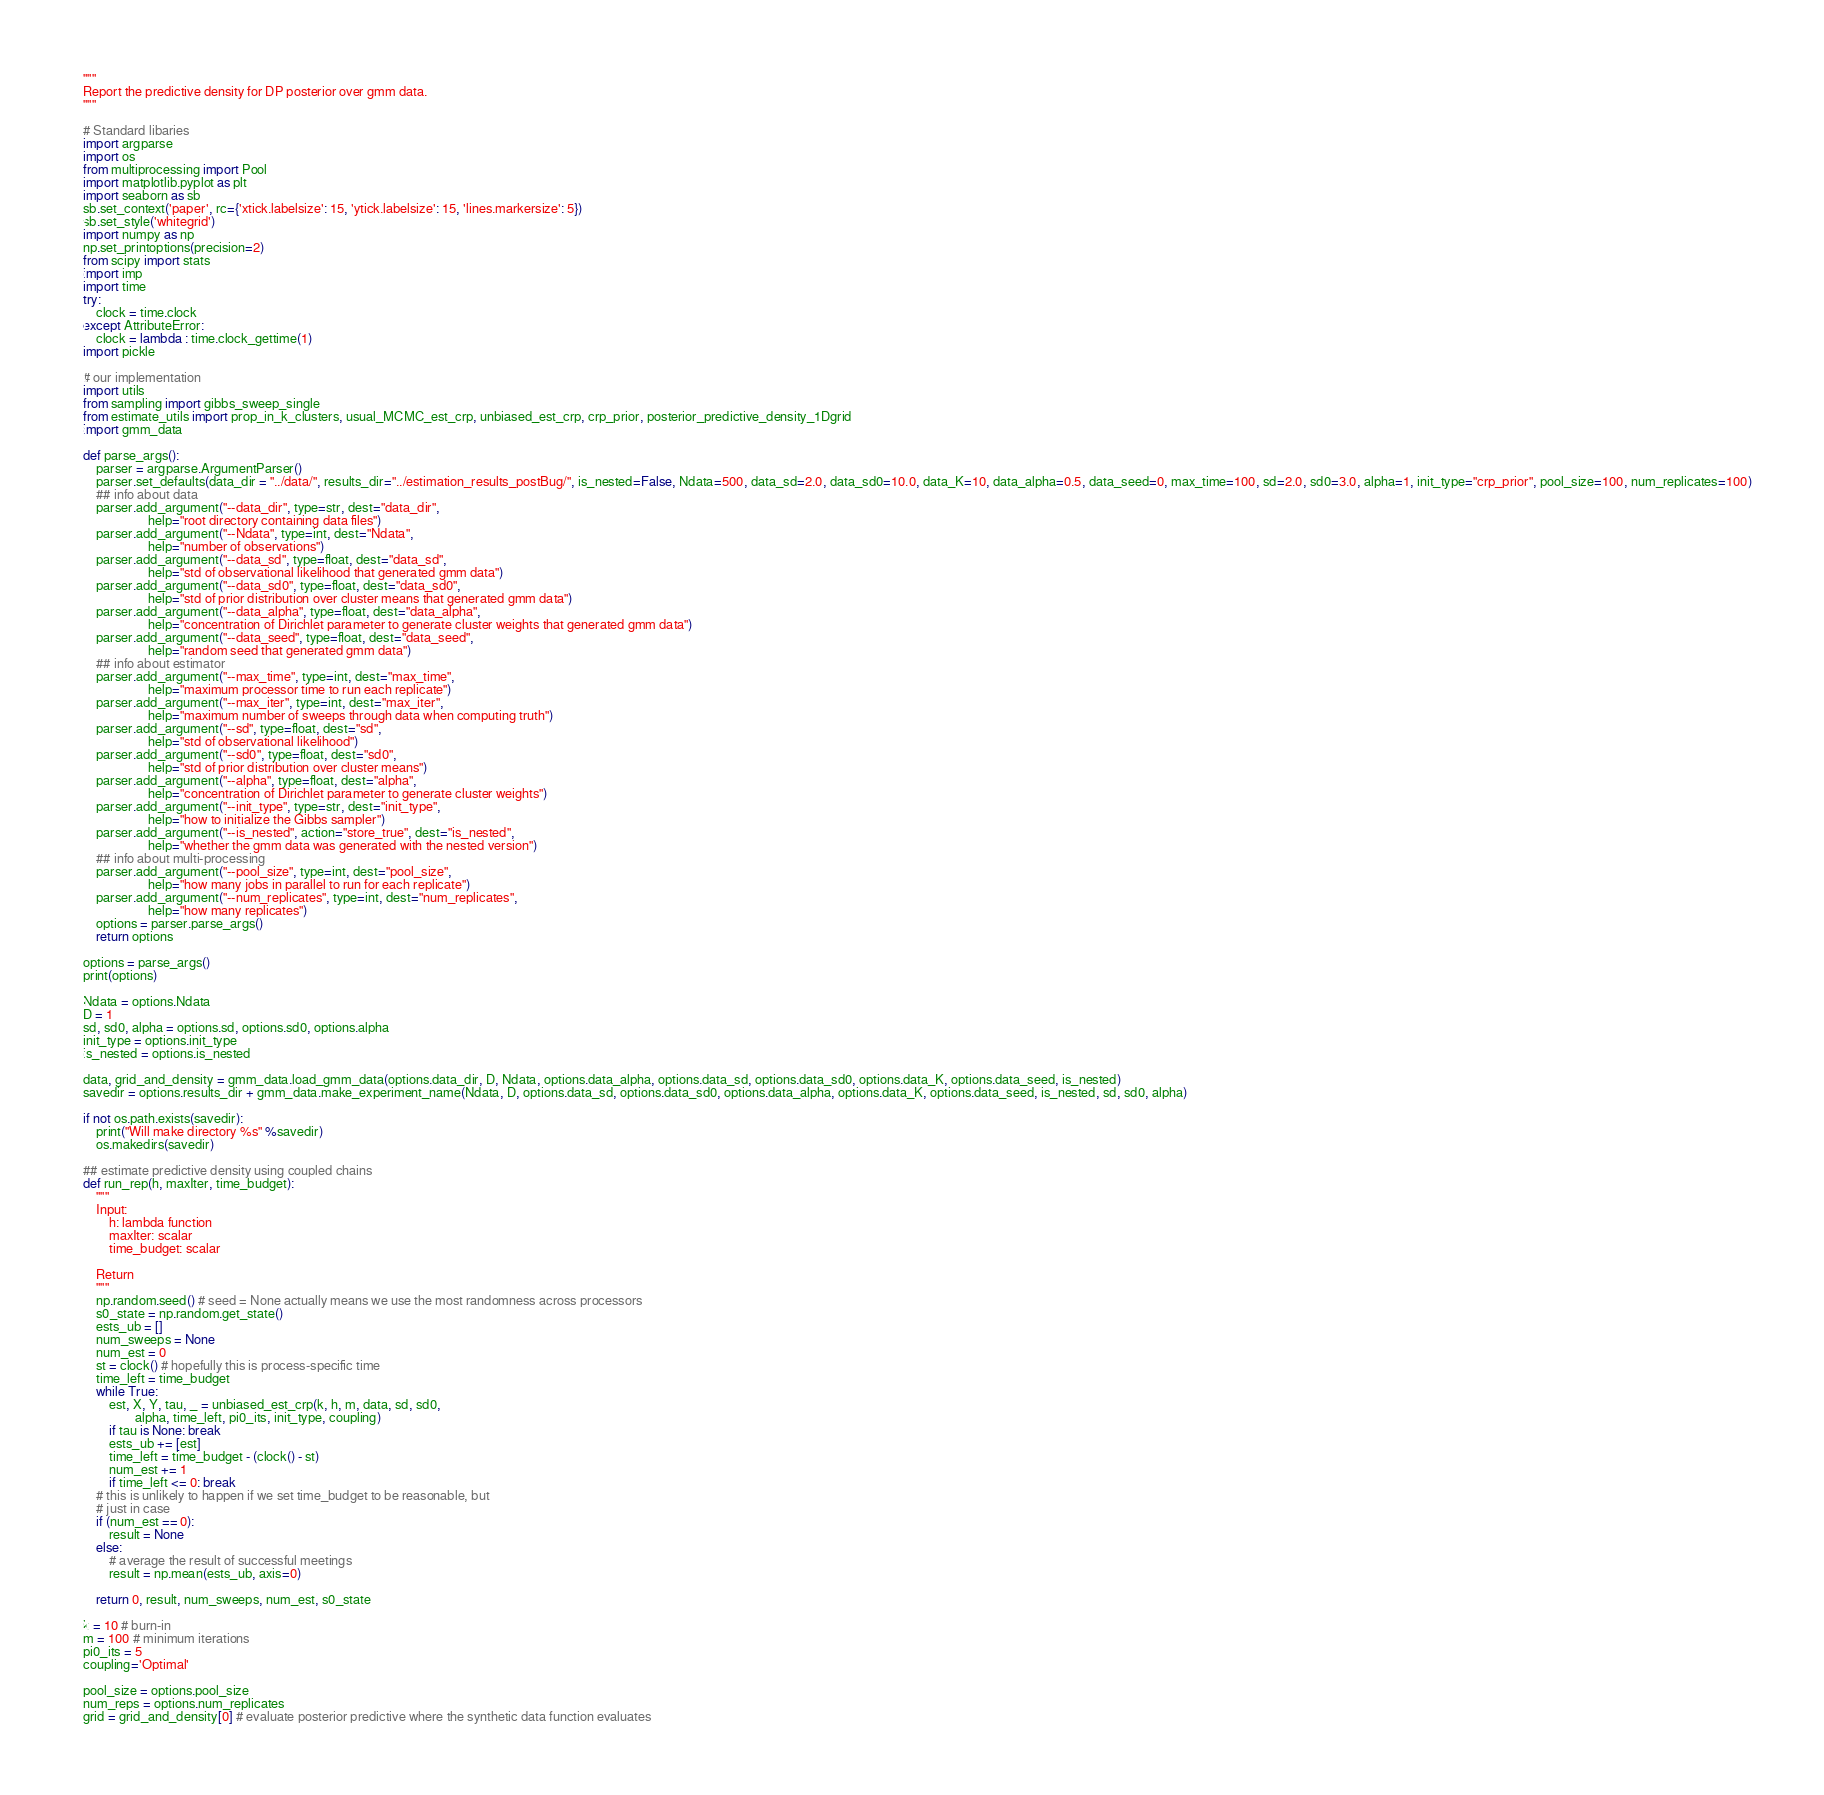Convert code to text. <code><loc_0><loc_0><loc_500><loc_500><_Python_>"""
Report the predictive density for DP posterior over gmm data.
"""

# Standard libaries 
import argparse
import os
from multiprocessing import Pool
import matplotlib.pyplot as plt
import seaborn as sb
sb.set_context('paper', rc={'xtick.labelsize': 15, 'ytick.labelsize': 15, 'lines.markersize': 5})
sb.set_style('whitegrid')
import numpy as np
np.set_printoptions(precision=2)
from scipy import stats
import imp
import time
try:
    clock = time.clock
except AttributeError:
    clock = lambda : time.clock_gettime(1)
import pickle

# our implementation 
import utils
from sampling import gibbs_sweep_single
from estimate_utils import prop_in_k_clusters, usual_MCMC_est_crp, unbiased_est_crp, crp_prior, posterior_predictive_density_1Dgrid
import gmm_data

def parse_args():
    parser = argparse.ArgumentParser()
    parser.set_defaults(data_dir = "../data/", results_dir="../estimation_results_postBug/", is_nested=False, Ndata=500, data_sd=2.0, data_sd0=10.0, data_K=10, data_alpha=0.5, data_seed=0, max_time=100, sd=2.0, sd0=3.0, alpha=1, init_type="crp_prior", pool_size=100, num_replicates=100)
    ## info about data
    parser.add_argument("--data_dir", type=str, dest="data_dir",
                    help="root directory containing data files")
    parser.add_argument("--Ndata", type=int, dest="Ndata",
                    help="number of observations")
    parser.add_argument("--data_sd", type=float, dest="data_sd",
                    help="std of observational likelihood that generated gmm data")
    parser.add_argument("--data_sd0", type=float, dest="data_sd0",
                    help="std of prior distribution over cluster means that generated gmm data")
    parser.add_argument("--data_alpha", type=float, dest="data_alpha",
                    help="concentration of Dirichlet parameter to generate cluster weights that generated gmm data")
    parser.add_argument("--data_seed", type=float, dest="data_seed",
                    help="random seed that generated gmm data")
    ## info about estimator
    parser.add_argument("--max_time", type=int, dest="max_time",
                    help="maximum processor time to run each replicate")
    parser.add_argument("--max_iter", type=int, dest="max_iter",
                    help="maximum number of sweeps through data when computing truth")
    parser.add_argument("--sd", type=float, dest="sd",
                    help="std of observational likelihood")
    parser.add_argument("--sd0", type=float, dest="sd0",
                    help="std of prior distribution over cluster means")
    parser.add_argument("--alpha", type=float, dest="alpha",
                    help="concentration of Dirichlet parameter to generate cluster weights")
    parser.add_argument("--init_type", type=str, dest="init_type",
                    help="how to initialize the Gibbs sampler")
    parser.add_argument("--is_nested", action="store_true", dest="is_nested",
                    help="whether the gmm data was generated with the nested version")
    ## info about multi-processing
    parser.add_argument("--pool_size", type=int, dest="pool_size",
                    help="how many jobs in parallel to run for each replicate")
    parser.add_argument("--num_replicates", type=int, dest="num_replicates",
                    help="how many replicates")
    options = parser.parse_args()
    return options 

options = parse_args()
print(options)

Ndata = options.Ndata
D = 1
sd, sd0, alpha = options.sd, options.sd0, options.alpha
init_type = options.init_type
is_nested = options.is_nested

data, grid_and_density = gmm_data.load_gmm_data(options.data_dir, D, Ndata, options.data_alpha, options.data_sd, options.data_sd0, options.data_K, options.data_seed, is_nested)
savedir = options.results_dir + gmm_data.make_experiment_name(Ndata, D, options.data_sd, options.data_sd0, options.data_alpha, options.data_K, options.data_seed, is_nested, sd, sd0, alpha)

if not os.path.exists(savedir):
    print("Will make directory %s" %savedir)
    os.makedirs(savedir)
    
## estimate predictive density using coupled chains
def run_rep(h, maxIter, time_budget):
    """
    Input:
        h: lambda function
        maxIter: scalar 
        time_budget: scalar
        
    Return 
    """
    np.random.seed() # seed = None actually means we use the most randomness across processors
    s0_state = np.random.get_state()
    ests_ub = []
    num_sweeps = None
    num_est = 0
    st = clock() # hopefully this is process-specific time
    time_left = time_budget
    while True:
        est, X, Y, tau, _ = unbiased_est_crp(k, h, m, data, sd, sd0,
                alpha, time_left, pi0_its, init_type, coupling)
        if tau is None: break
        ests_ub += [est]
        time_left = time_budget - (clock() - st)
        num_est += 1
        if time_left <= 0: break
    # this is unlikely to happen if we set time_budget to be reasonable, but
    # just in case
    if (num_est == 0):
        result = None
    else:
        # average the result of successful meetings
        result = np.mean(ests_ub, axis=0)

    return 0, result, num_sweeps, num_est, s0_state

k = 10 # burn-in
m = 100 # minimum iterations
pi0_its = 5
coupling='Optimal'

pool_size = options.pool_size
num_reps = options.num_replicates
grid = grid_and_density[0] # evaluate posterior predictive where the synthetic data function evaluates
</code> 